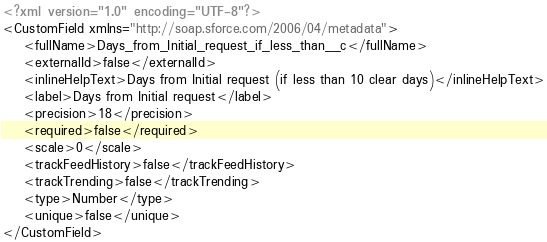<code> <loc_0><loc_0><loc_500><loc_500><_XML_><?xml version="1.0" encoding="UTF-8"?>
<CustomField xmlns="http://soap.sforce.com/2006/04/metadata">
    <fullName>Days_from_Initial_request_if_less_than__c</fullName>
    <externalId>false</externalId>
    <inlineHelpText>Days from Initial request (if less than 10 clear days)</inlineHelpText>
    <label>Days from Initial request</label>
    <precision>18</precision>
    <required>false</required>
    <scale>0</scale>
    <trackFeedHistory>false</trackFeedHistory>
    <trackTrending>false</trackTrending>
    <type>Number</type>
    <unique>false</unique>
</CustomField>
</code> 